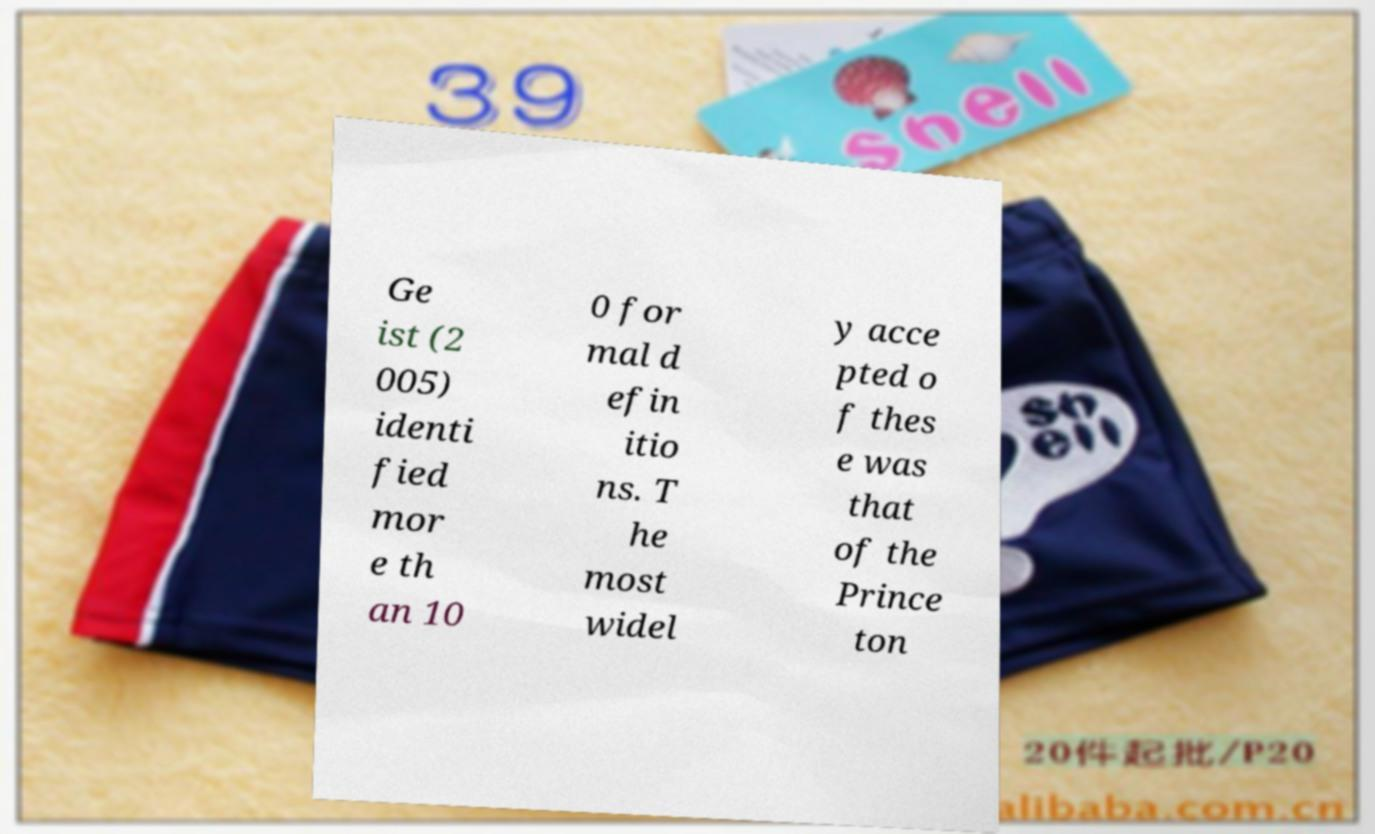Can you accurately transcribe the text from the provided image for me? Ge ist (2 005) identi fied mor e th an 10 0 for mal d efin itio ns. T he most widel y acce pted o f thes e was that of the Prince ton 